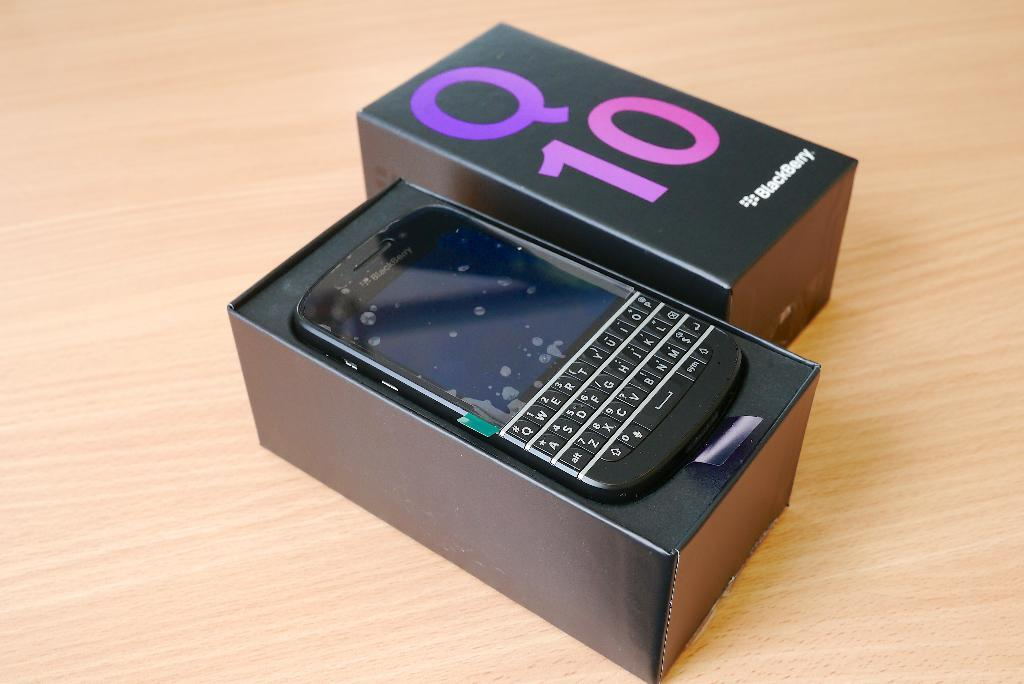Provide a one-sentence caption for the provided image. An open box containing a Blackberry Q10 cell phone. 